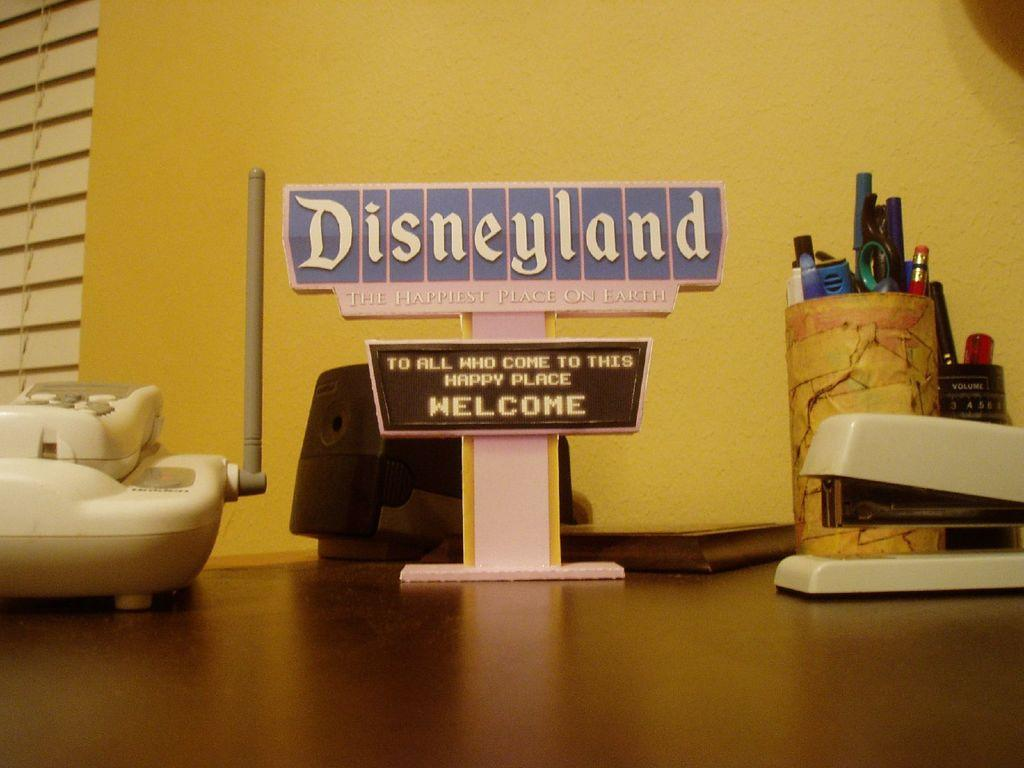What communication device is present in the image? There is a telephone in the image. What is the purpose of the name board with a stand? The name board with a stand is likely used for identification or displaying information. What other objects can be seen on the table? There are other objects on the table, but their specific details are not mentioned in the provided facts. What can be seen in the background of the image? There is a wall in the background of the image. Where is the toothbrush located in the image? There is no toothbrush present in the image. What type of park can be seen in the background of the image? There is no park visible in the image; it only shows a wall in the background. 